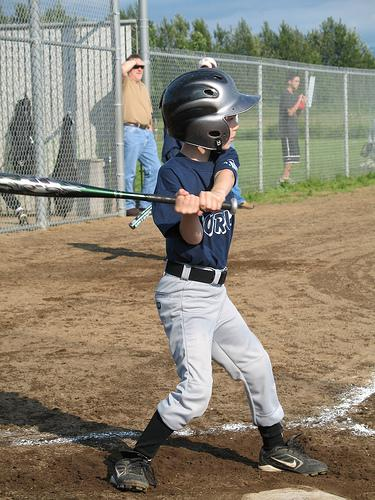Question: how many bats is the kid holding?
Choices:
A. 1.
B. 2.
C. 6.
D. 8.
Answer with the letter. Answer: A Question: what color is the player's helmet?
Choices:
A. Blue.
B. Orange.
C. White.
D. Black.
Answer with the letter. Answer: D Question: what game is being played?
Choices:
A. Soccer.
B. Bowling.
C. Baseball.
D. Hockey.
Answer with the letter. Answer: C 